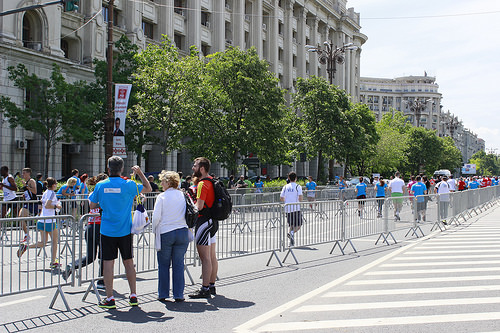<image>
Can you confirm if the sign is to the left of the person? Yes. From this viewpoint, the sign is positioned to the left side relative to the person. 